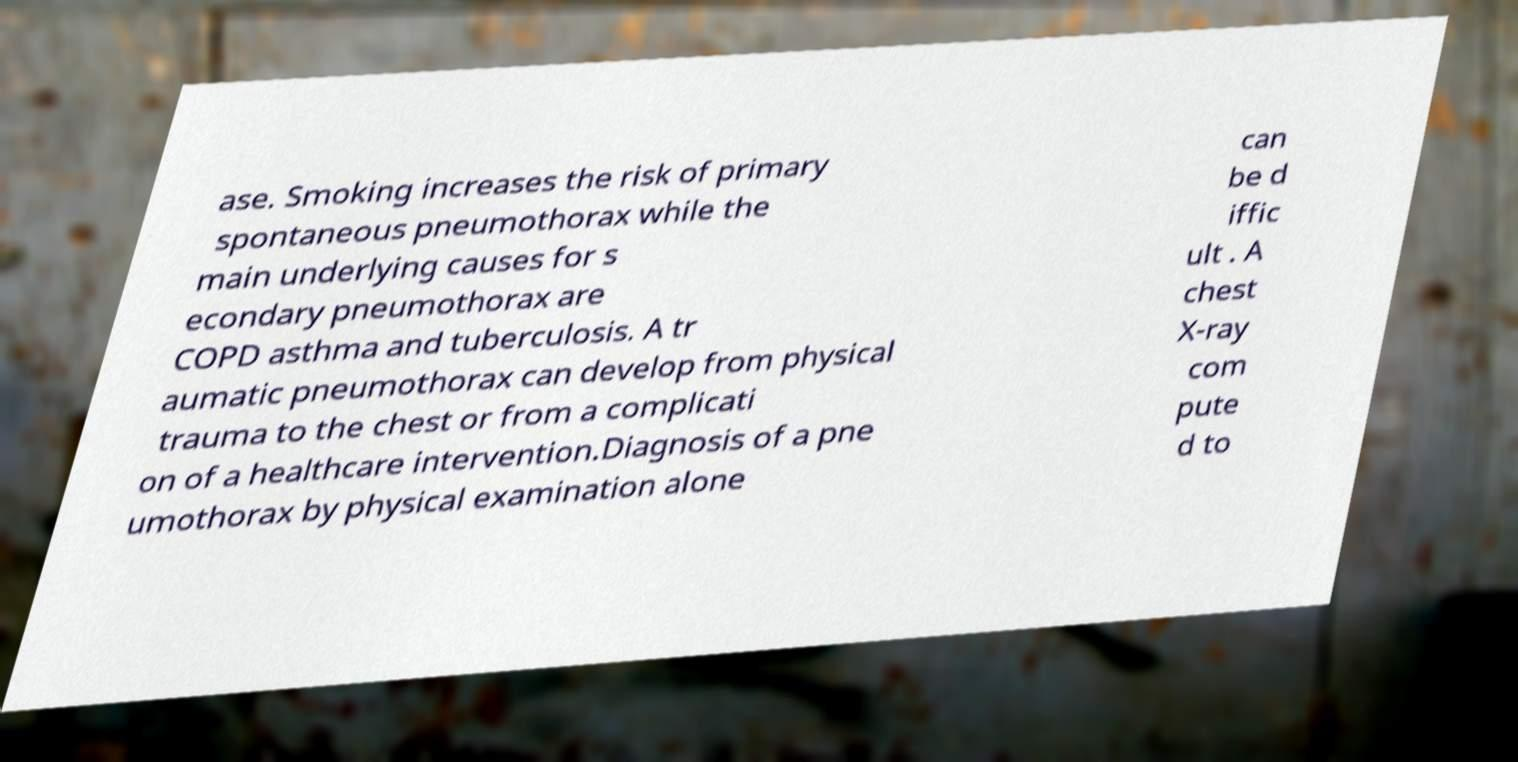Please read and relay the text visible in this image. What does it say? ase. Smoking increases the risk of primary spontaneous pneumothorax while the main underlying causes for s econdary pneumothorax are COPD asthma and tuberculosis. A tr aumatic pneumothorax can develop from physical trauma to the chest or from a complicati on of a healthcare intervention.Diagnosis of a pne umothorax by physical examination alone can be d iffic ult . A chest X-ray com pute d to 